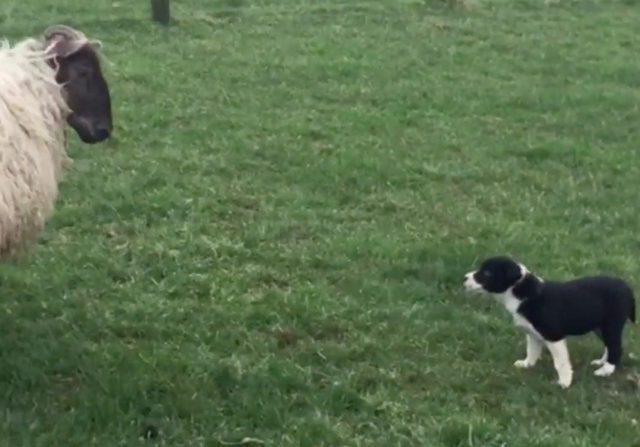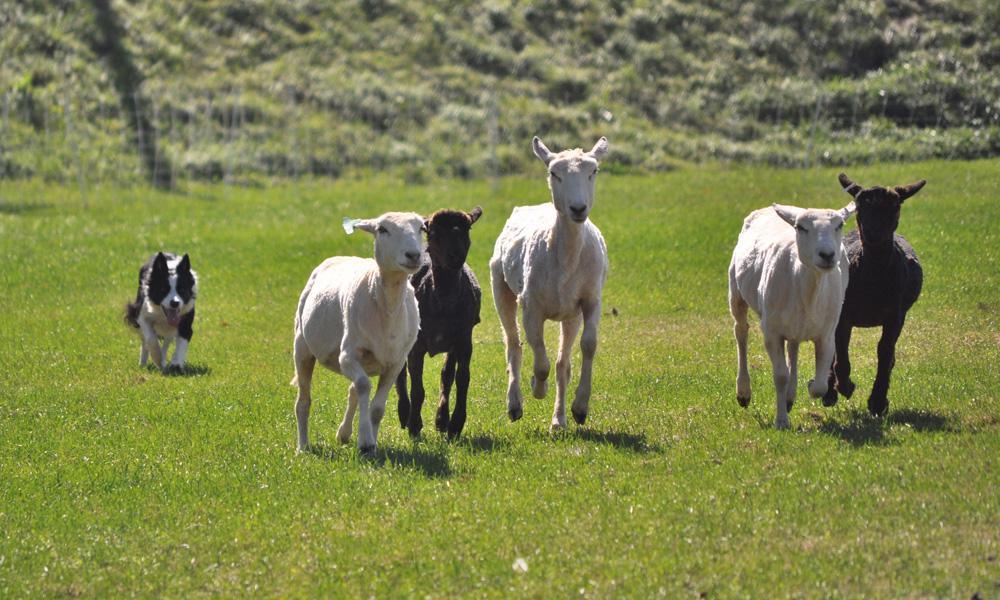The first image is the image on the left, the second image is the image on the right. Considering the images on both sides, is "One of the images shows exactly one dog with one sheep." valid? Answer yes or no. Yes. The first image is the image on the left, the second image is the image on the right. Examine the images to the left and right. Is the description "An image shows one dog in foreground facing a mass of sheep at the rear of image." accurate? Answer yes or no. No. 